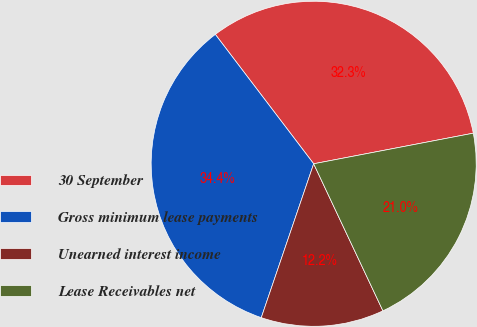<chart> <loc_0><loc_0><loc_500><loc_500><pie_chart><fcel>30 September<fcel>Gross minimum lease payments<fcel>Unearned interest income<fcel>Lease Receivables net<nl><fcel>32.33%<fcel>34.43%<fcel>12.23%<fcel>21.01%<nl></chart> 